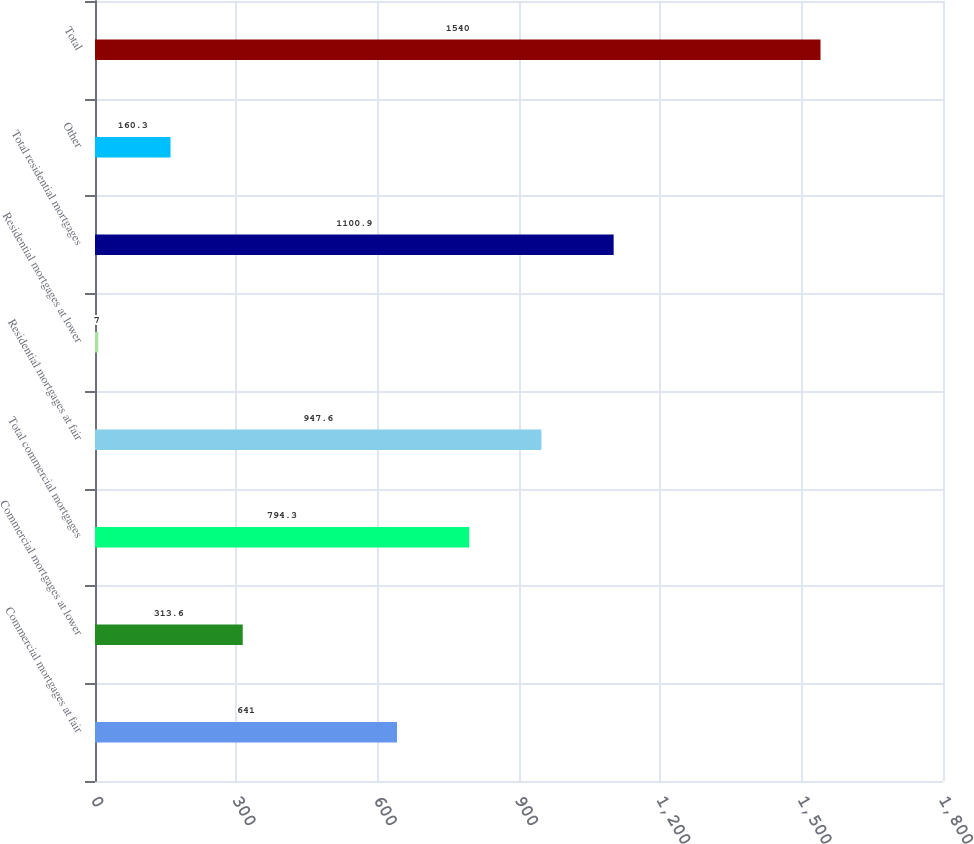Convert chart. <chart><loc_0><loc_0><loc_500><loc_500><bar_chart><fcel>Commercial mortgages at fair<fcel>Commercial mortgages at lower<fcel>Total commercial mortgages<fcel>Residential mortgages at fair<fcel>Residential mortgages at lower<fcel>Total residential mortgages<fcel>Other<fcel>Total<nl><fcel>641<fcel>313.6<fcel>794.3<fcel>947.6<fcel>7<fcel>1100.9<fcel>160.3<fcel>1540<nl></chart> 